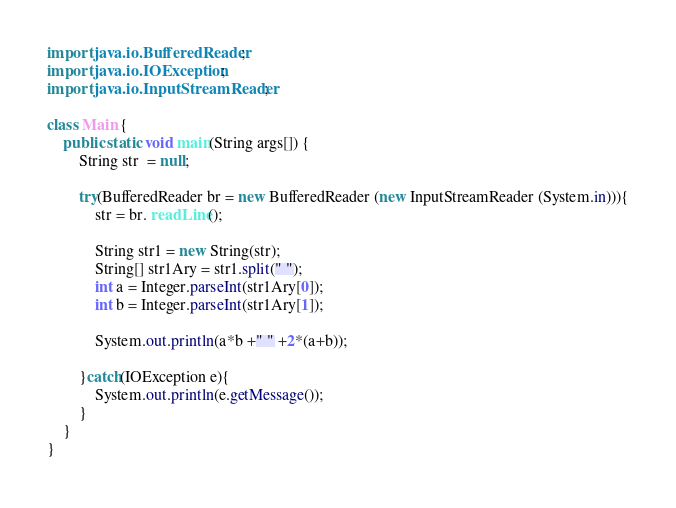Convert code to text. <code><loc_0><loc_0><loc_500><loc_500><_Java_>import java.io.BufferedReader;
import java.io.IOException;
import java.io.InputStreamReader;

class Main {
	public static void main(String args[]) {
		String str  = null;

		try(BufferedReader br = new BufferedReader (new InputStreamReader (System.in))){
			str = br. readLine();

			String str1 = new String(str);
			String[] str1Ary = str1.split(" ");
			int a = Integer.parseInt(str1Ary[0]);
			int b = Integer.parseInt(str1Ary[1]);

			System.out.println(a*b +" " +2*(a+b));
			
		}catch(IOException e){
			System.out.println(e.getMessage());
		}
	}
}</code> 